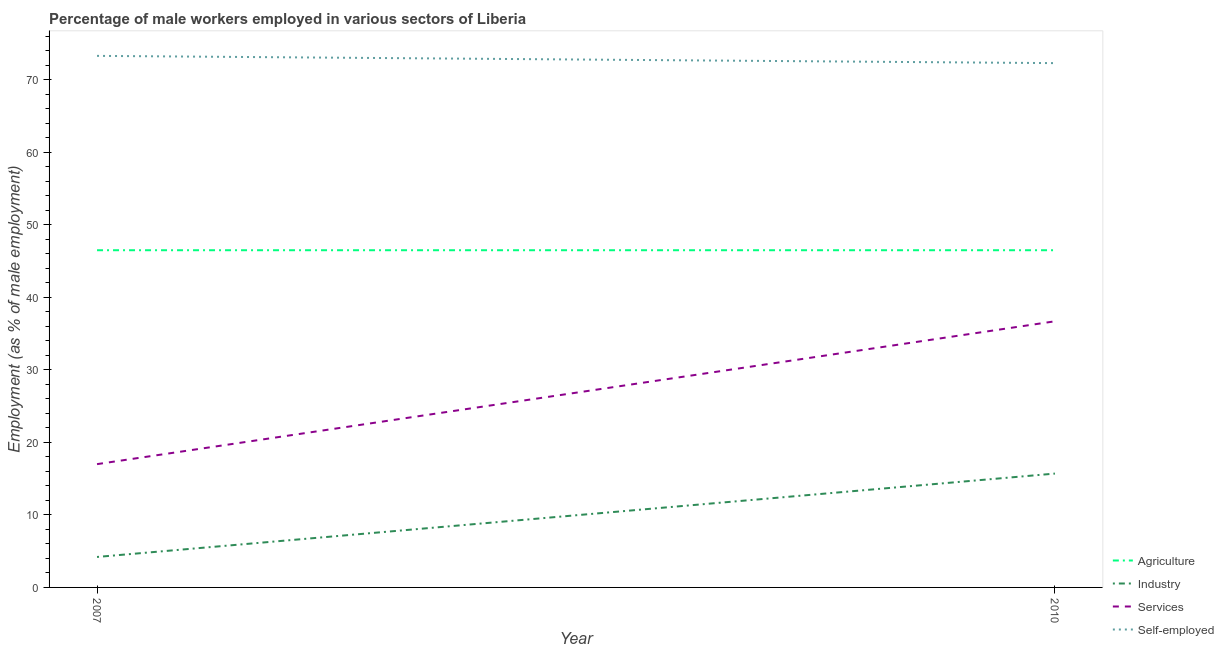How many different coloured lines are there?
Your response must be concise. 4. Is the number of lines equal to the number of legend labels?
Give a very brief answer. Yes. What is the percentage of male workers in services in 2010?
Your answer should be compact. 36.7. Across all years, what is the maximum percentage of male workers in agriculture?
Offer a terse response. 46.5. Across all years, what is the minimum percentage of male workers in agriculture?
Offer a very short reply. 46.5. In which year was the percentage of male workers in services minimum?
Your answer should be very brief. 2007. What is the total percentage of male workers in services in the graph?
Your response must be concise. 53.7. What is the difference between the percentage of male workers in agriculture in 2007 and that in 2010?
Keep it short and to the point. 0. What is the difference between the percentage of self employed male workers in 2007 and the percentage of male workers in industry in 2010?
Provide a short and direct response. 57.6. What is the average percentage of self employed male workers per year?
Offer a very short reply. 72.8. In the year 2010, what is the difference between the percentage of male workers in agriculture and percentage of self employed male workers?
Your response must be concise. -25.8. In how many years, is the percentage of self employed male workers greater than 60 %?
Provide a succinct answer. 2. In how many years, is the percentage of male workers in agriculture greater than the average percentage of male workers in agriculture taken over all years?
Offer a terse response. 0. Is it the case that in every year, the sum of the percentage of male workers in services and percentage of male workers in agriculture is greater than the sum of percentage of male workers in industry and percentage of self employed male workers?
Provide a short and direct response. Yes. How many lines are there?
Offer a very short reply. 4. What is the difference between two consecutive major ticks on the Y-axis?
Your answer should be very brief. 10. Are the values on the major ticks of Y-axis written in scientific E-notation?
Keep it short and to the point. No. Does the graph contain grids?
Offer a terse response. No. Where does the legend appear in the graph?
Ensure brevity in your answer.  Bottom right. How many legend labels are there?
Give a very brief answer. 4. How are the legend labels stacked?
Offer a very short reply. Vertical. What is the title of the graph?
Keep it short and to the point. Percentage of male workers employed in various sectors of Liberia. Does "Building human resources" appear as one of the legend labels in the graph?
Provide a short and direct response. No. What is the label or title of the Y-axis?
Make the answer very short. Employment (as % of male employment). What is the Employment (as % of male employment) of Agriculture in 2007?
Your response must be concise. 46.5. What is the Employment (as % of male employment) of Industry in 2007?
Your answer should be compact. 4.2. What is the Employment (as % of male employment) in Services in 2007?
Offer a very short reply. 17. What is the Employment (as % of male employment) of Self-employed in 2007?
Provide a succinct answer. 73.3. What is the Employment (as % of male employment) in Agriculture in 2010?
Ensure brevity in your answer.  46.5. What is the Employment (as % of male employment) in Industry in 2010?
Give a very brief answer. 15.7. What is the Employment (as % of male employment) in Services in 2010?
Your answer should be very brief. 36.7. What is the Employment (as % of male employment) in Self-employed in 2010?
Provide a succinct answer. 72.3. Across all years, what is the maximum Employment (as % of male employment) of Agriculture?
Make the answer very short. 46.5. Across all years, what is the maximum Employment (as % of male employment) of Industry?
Your response must be concise. 15.7. Across all years, what is the maximum Employment (as % of male employment) in Services?
Ensure brevity in your answer.  36.7. Across all years, what is the maximum Employment (as % of male employment) of Self-employed?
Ensure brevity in your answer.  73.3. Across all years, what is the minimum Employment (as % of male employment) of Agriculture?
Your answer should be very brief. 46.5. Across all years, what is the minimum Employment (as % of male employment) in Industry?
Provide a short and direct response. 4.2. Across all years, what is the minimum Employment (as % of male employment) of Services?
Give a very brief answer. 17. Across all years, what is the minimum Employment (as % of male employment) of Self-employed?
Provide a succinct answer. 72.3. What is the total Employment (as % of male employment) of Agriculture in the graph?
Your response must be concise. 93. What is the total Employment (as % of male employment) in Services in the graph?
Provide a succinct answer. 53.7. What is the total Employment (as % of male employment) of Self-employed in the graph?
Offer a terse response. 145.6. What is the difference between the Employment (as % of male employment) of Agriculture in 2007 and that in 2010?
Offer a terse response. 0. What is the difference between the Employment (as % of male employment) of Services in 2007 and that in 2010?
Provide a succinct answer. -19.7. What is the difference between the Employment (as % of male employment) in Self-employed in 2007 and that in 2010?
Offer a terse response. 1. What is the difference between the Employment (as % of male employment) in Agriculture in 2007 and the Employment (as % of male employment) in Industry in 2010?
Offer a very short reply. 30.8. What is the difference between the Employment (as % of male employment) of Agriculture in 2007 and the Employment (as % of male employment) of Self-employed in 2010?
Give a very brief answer. -25.8. What is the difference between the Employment (as % of male employment) of Industry in 2007 and the Employment (as % of male employment) of Services in 2010?
Give a very brief answer. -32.5. What is the difference between the Employment (as % of male employment) in Industry in 2007 and the Employment (as % of male employment) in Self-employed in 2010?
Provide a succinct answer. -68.1. What is the difference between the Employment (as % of male employment) of Services in 2007 and the Employment (as % of male employment) of Self-employed in 2010?
Give a very brief answer. -55.3. What is the average Employment (as % of male employment) in Agriculture per year?
Offer a terse response. 46.5. What is the average Employment (as % of male employment) in Industry per year?
Offer a terse response. 9.95. What is the average Employment (as % of male employment) in Services per year?
Provide a short and direct response. 26.85. What is the average Employment (as % of male employment) of Self-employed per year?
Keep it short and to the point. 72.8. In the year 2007, what is the difference between the Employment (as % of male employment) in Agriculture and Employment (as % of male employment) in Industry?
Ensure brevity in your answer.  42.3. In the year 2007, what is the difference between the Employment (as % of male employment) in Agriculture and Employment (as % of male employment) in Services?
Give a very brief answer. 29.5. In the year 2007, what is the difference between the Employment (as % of male employment) in Agriculture and Employment (as % of male employment) in Self-employed?
Provide a succinct answer. -26.8. In the year 2007, what is the difference between the Employment (as % of male employment) of Industry and Employment (as % of male employment) of Services?
Keep it short and to the point. -12.8. In the year 2007, what is the difference between the Employment (as % of male employment) in Industry and Employment (as % of male employment) in Self-employed?
Your response must be concise. -69.1. In the year 2007, what is the difference between the Employment (as % of male employment) in Services and Employment (as % of male employment) in Self-employed?
Provide a short and direct response. -56.3. In the year 2010, what is the difference between the Employment (as % of male employment) in Agriculture and Employment (as % of male employment) in Industry?
Your response must be concise. 30.8. In the year 2010, what is the difference between the Employment (as % of male employment) in Agriculture and Employment (as % of male employment) in Services?
Make the answer very short. 9.8. In the year 2010, what is the difference between the Employment (as % of male employment) in Agriculture and Employment (as % of male employment) in Self-employed?
Provide a short and direct response. -25.8. In the year 2010, what is the difference between the Employment (as % of male employment) in Industry and Employment (as % of male employment) in Self-employed?
Keep it short and to the point. -56.6. In the year 2010, what is the difference between the Employment (as % of male employment) of Services and Employment (as % of male employment) of Self-employed?
Your answer should be very brief. -35.6. What is the ratio of the Employment (as % of male employment) of Industry in 2007 to that in 2010?
Provide a short and direct response. 0.27. What is the ratio of the Employment (as % of male employment) in Services in 2007 to that in 2010?
Your response must be concise. 0.46. What is the ratio of the Employment (as % of male employment) in Self-employed in 2007 to that in 2010?
Give a very brief answer. 1.01. What is the difference between the highest and the second highest Employment (as % of male employment) of Industry?
Offer a terse response. 11.5. What is the difference between the highest and the second highest Employment (as % of male employment) of Services?
Offer a terse response. 19.7. What is the difference between the highest and the second highest Employment (as % of male employment) of Self-employed?
Offer a very short reply. 1. What is the difference between the highest and the lowest Employment (as % of male employment) of Agriculture?
Provide a succinct answer. 0. What is the difference between the highest and the lowest Employment (as % of male employment) in Industry?
Your answer should be very brief. 11.5. What is the difference between the highest and the lowest Employment (as % of male employment) of Services?
Provide a succinct answer. 19.7. 